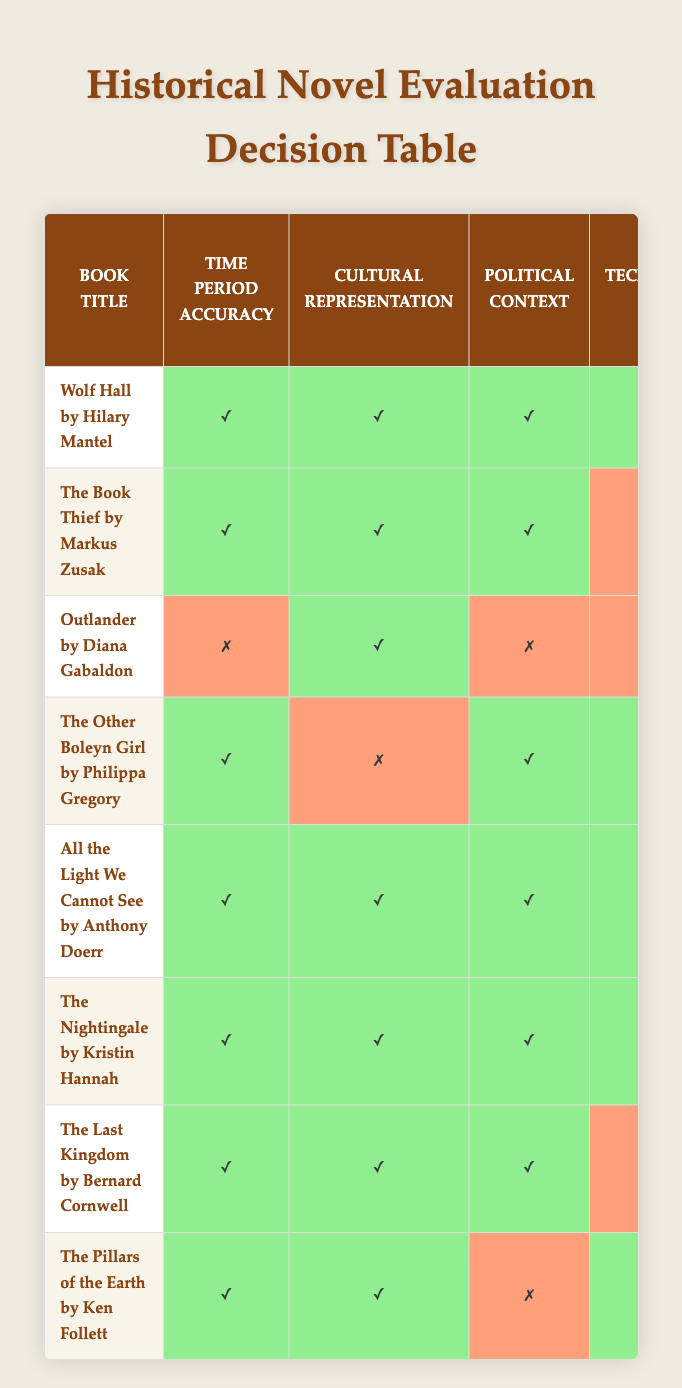What books are recommended for book club? By scanning the 'Recommend for book club' column, we find that the following books are marked with '✓' for recommendation: 'Wolf Hall', 'The Book Thief', 'Outlander', 'The Other Boleyn Girl', 'All the Light We Cannot See', 'The Nightingale', 'The Last Kingdom', and 'The Pillars of the Earth'.
Answer: Wolf Hall, The Book Thief, Outlander, The Other Boleyn Girl, All the Light We Cannot See, The Nightingale, The Last Kingdom, The Pillars of the Earth Which book(s) could be used as teaching material? Again, by reviewing the 'Use as teaching material' column, we see the books with '✓' are 'Wolf Hall', 'The Book Thief', 'All the Light We Cannot See', 'The Nightingale', 'The Last Kingdom', and 'The Pillars of the Earth'.
Answer: Wolf Hall, The Book Thief, All the Light We Cannot See, The Nightingale, The Last Kingdom, The Pillars of the Earth Is 'Outlander' highlighted as exemplary historical fiction? In the 'Highlight as exemplary historical fiction' column, we can see that 'Outlander' is marked with '✗', indicating it is not considered exemplary historical fiction.
Answer: No How many books accurately represent their time period? By checking the 'Time period accuracy' column, we can count how many books have '✓'. The books are: 'Wolf Hall', 'The Book Thief', 'The Other Boleyn Girl', 'All the Light We Cannot See', 'The Nightingale', 'The Last Kingdom', and 'The Pillars of the Earth', totaling 7 books.
Answer: 7 Which book has the greatest number of '✓' across the categories? We need to assess each book by counting the '✓' values in each row. 'All the Light We Cannot See' has '✓' in all conditions and is listed as 8 '✓' in total.
Answer: All the Light We Cannot See Is there any book with both political context and social norms depiction marked as accurate? By looking at the columns 'Political context' and 'Social norms depiction', the books that show '✓' in both categories are 'Wolf Hall' and 'The Last Kingdom'.
Answer: Yes Which book has a discrepancy in technological aspects but is recommended for book club? Here, we observe the 'Technological aspects' where 'The Nightingale' has '✓' for recommendation yet '✗' for accuracy in technological aspects, indicating a discrepancy.
Answer: The Nightingale How many books depict social norms accurately but do not have a comprehensive representation in all aspects? By filtering for the category 'Social norms depiction' as '✓', we note the books are 'Wolf Hall', 'The Book Thief', 'Outlander', and 'The Last Kingdom', but 'Outlander' fails in multiple categories, totaling 4 books with discrepancies.
Answer: 4 